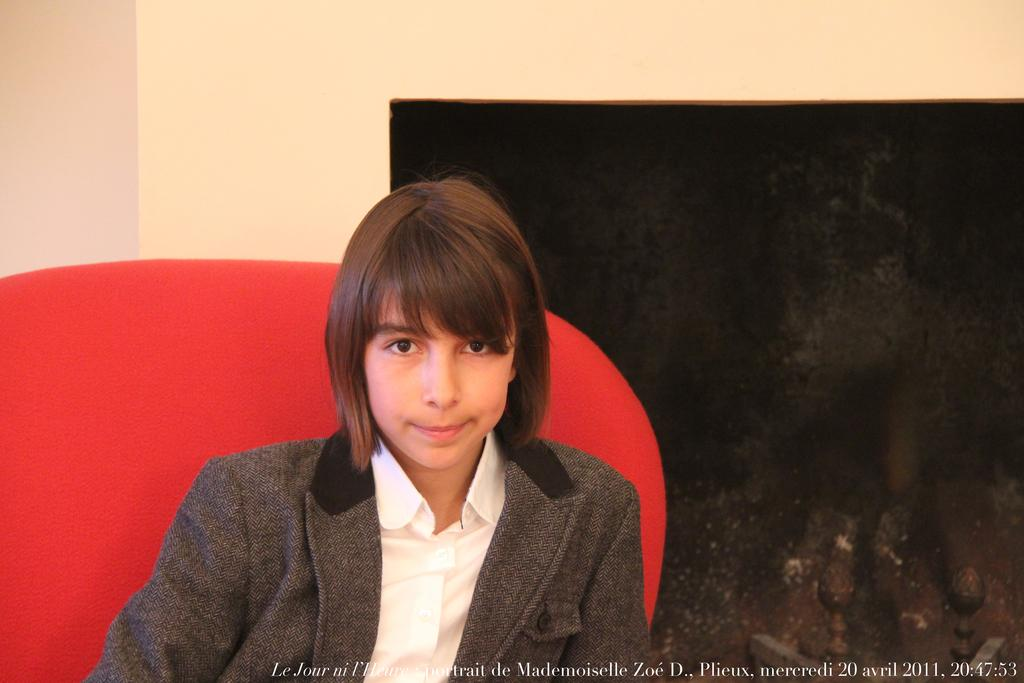Who is the main subject in the image? There is a girl in the image. What is the girl sitting on? The girl is sitting on a red color sofa. What is the girl wearing? The girl is wearing a white shirt and a grey coat. What can be seen behind the girl? There is a background wall in the image. What architectural feature is present in the image? There is a chimney present in the image. How many airplanes are flying in the image? There are no airplanes present in the image. What observation can be made about the number of chimneys in the image? There is only one chimney present in the image. 